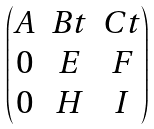<formula> <loc_0><loc_0><loc_500><loc_500>\begin{pmatrix} A & B t & C t \\ 0 & E & F \\ 0 & H & I \end{pmatrix}</formula> 